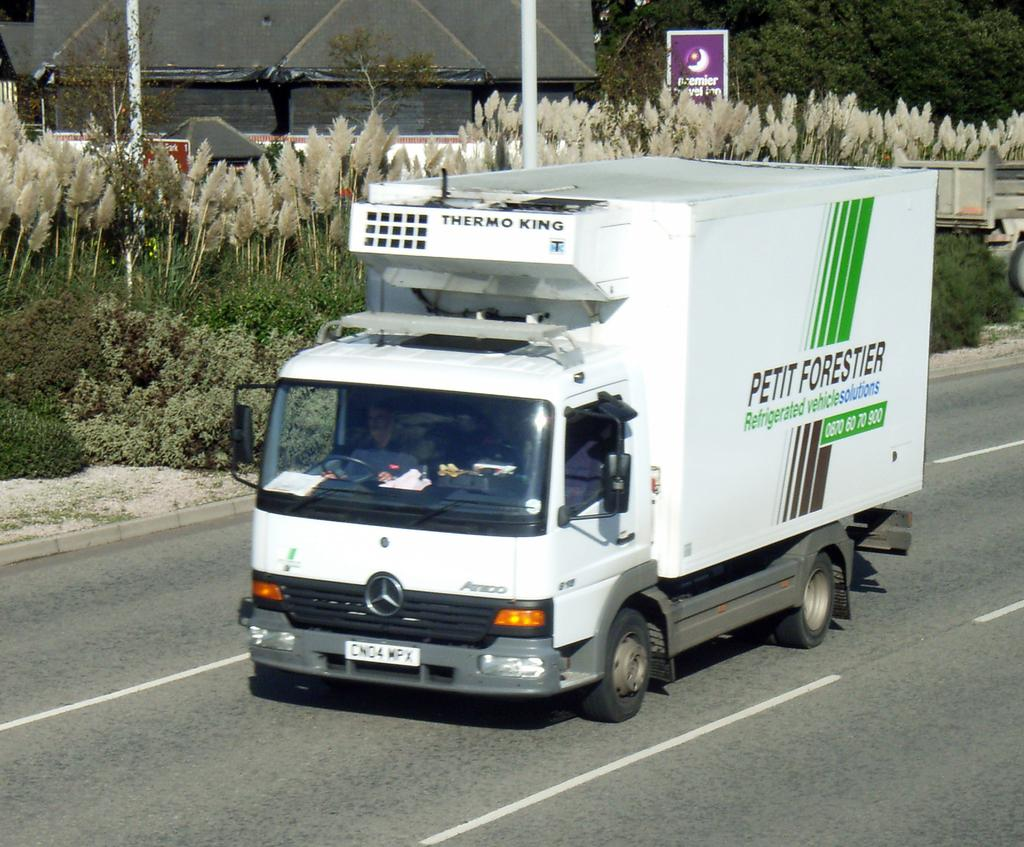What is the main subject of the image? The main subject of the image is a van on the road. Can you describe the van's occupant? There is a man inside the van. What can be seen in the background of the image? There are trees, plants, poles, boards, and a shed in the background of the image. What type of fang can be seen in the image? There is no fang present in the image. Can you describe the cub's interaction with the van in the image? There is no cub present in the image, so it cannot be interacting with the van. 